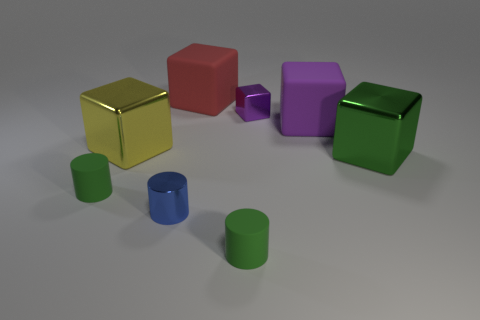How many brown things are either matte blocks or small objects?
Offer a very short reply. 0. What is the shape of the big yellow shiny object that is on the left side of the matte cylinder right of the blue cylinder?
Provide a succinct answer. Cube. Is the size of the shiny cylinder that is in front of the large red object the same as the object in front of the blue object?
Offer a very short reply. Yes. Are there any tiny purple blocks made of the same material as the big yellow thing?
Your answer should be very brief. Yes. There is a rubber object that is the same color as the small cube; what size is it?
Your answer should be very brief. Large. There is a big green object that is behind the small rubber thing that is to the right of the red thing; is there a big purple rubber object that is right of it?
Your answer should be compact. No. There is a green shiny block; are there any large matte cubes in front of it?
Your answer should be compact. No. What number of tiny purple things are in front of the metal cylinder in front of the big purple rubber thing?
Offer a very short reply. 0. There is a red rubber cube; does it have the same size as the metal cylinder in front of the green block?
Ensure brevity in your answer.  No. Is there a large object that has the same color as the small metallic block?
Ensure brevity in your answer.  Yes. 